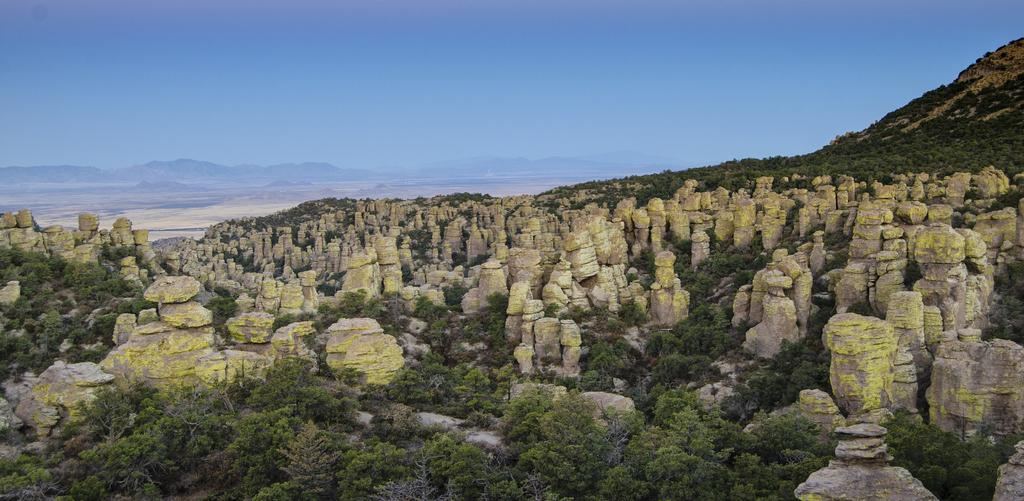What type of natural elements can be seen in the image? There are stones and trees visible in the image. What type of landscape is depicted in the background of the image? There are mountains visible in the background of the image. What is visible in the sky in the image? The sky is visible in the background of the image. What type of beef is being served at the feast in the image? There is no feast or beef present in the image; it features stones, trees, mountains, and the sky. 